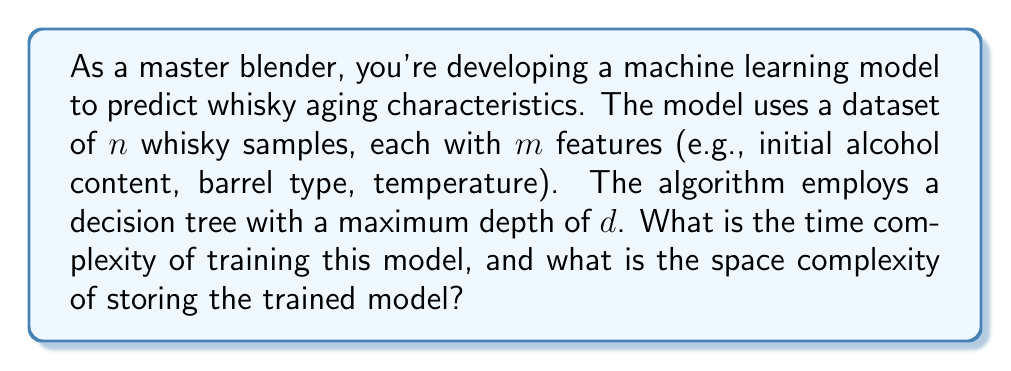Teach me how to tackle this problem. To analyze the time and space complexity of this machine learning model, we need to consider the decision tree algorithm's characteristics:

1. Time Complexity:
   The time complexity of training a decision tree depends on the number of samples ($n$), features ($m$), and the maximum depth ($d$) of the tree.

   a) At each node, the algorithm needs to evaluate all $m$ features to find the best split. This takes $O(m)$ time.
   b) For each feature, the algorithm needs to sort the samples, which takes $O(n \log n)$ time.
   c) The process is repeated for each level of the tree, up to a maximum depth of $d$.

   Therefore, the time complexity for training is:
   $$O(d \cdot m \cdot n \log n)$$

2. Space Complexity:
   The space complexity is determined by the structure of the trained decision tree.

   a) In the worst case, a binary decision tree with depth $d$ can have up to $2^d - 1$ nodes.
   b) Each node stores information about the feature and threshold used for splitting, which takes constant space.

   Thus, the space complexity for storing the trained model is:
   $$O(2^d)$$

It's important to note that this analysis assumes a worst-case scenario. In practice, the tree might not be fully balanced, and pruning techniques could be applied to reduce the model's size.

As a master blender, you should be aware that increasing the depth of the decision tree ($d$) will significantly increase both the training time and the model's storage requirements. This could impact the efficiency of predicting whisky aging characteristics, especially when dealing with large datasets of whisky samples.
Answer: Time complexity: $O(d \cdot m \cdot n \log n)$
Space complexity: $O(2^d)$ 